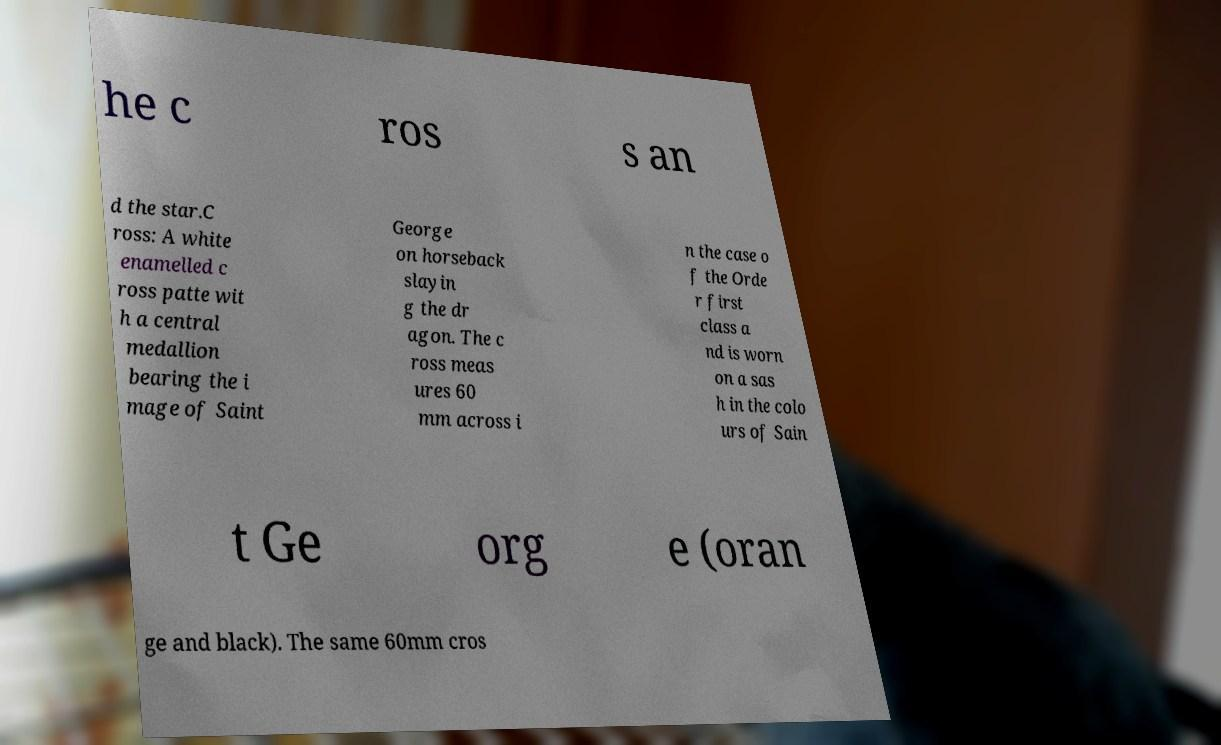For documentation purposes, I need the text within this image transcribed. Could you provide that? he c ros s an d the star.C ross: A white enamelled c ross patte wit h a central medallion bearing the i mage of Saint George on horseback slayin g the dr agon. The c ross meas ures 60 mm across i n the case o f the Orde r first class a nd is worn on a sas h in the colo urs of Sain t Ge org e (oran ge and black). The same 60mm cros 